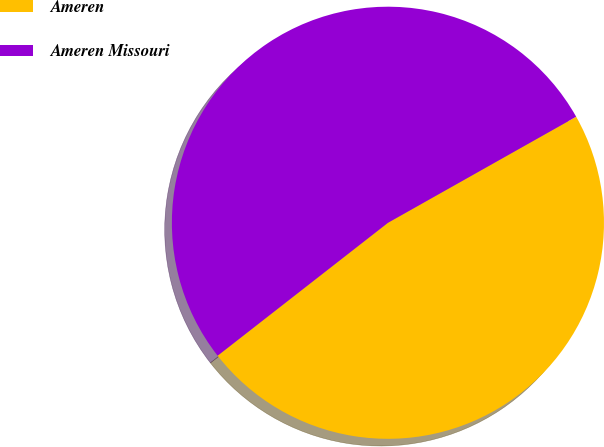Convert chart. <chart><loc_0><loc_0><loc_500><loc_500><pie_chart><fcel>Ameren<fcel>Ameren Missouri<nl><fcel>47.62%<fcel>52.38%<nl></chart> 